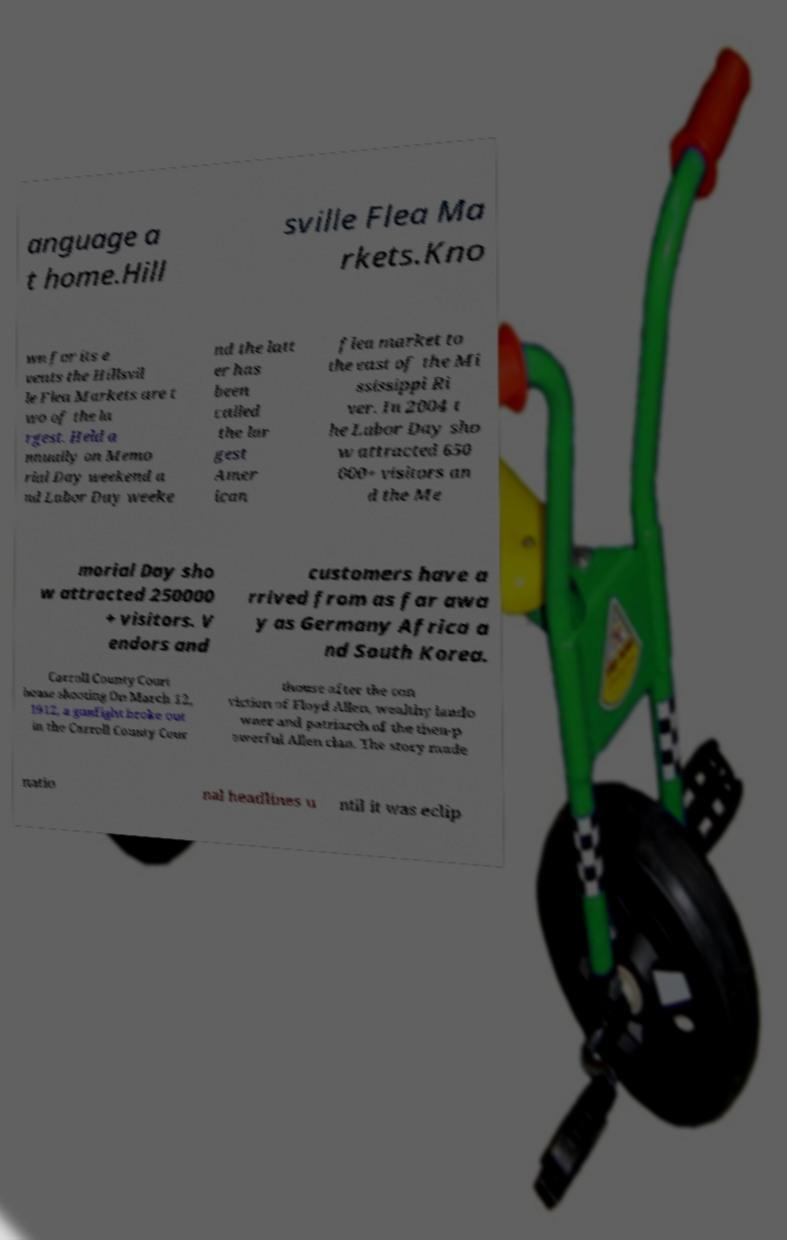Can you accurately transcribe the text from the provided image for me? anguage a t home.Hill sville Flea Ma rkets.Kno wn for its e vents the Hillsvil le Flea Markets are t wo of the la rgest. Held a nnually on Memo rial Day weekend a nd Labor Day weeke nd the latt er has been called the lar gest Amer ican flea market to the east of the Mi ssissippi Ri ver. In 2004 t he Labor Day sho w attracted 650 000+ visitors an d the Me morial Day sho w attracted 250000 + visitors. V endors and customers have a rrived from as far awa y as Germany Africa a nd South Korea. Carroll County Court house shooting.On March 12, 1912, a gunfight broke out in the Carroll County Cour thouse after the con viction of Floyd Allen, wealthy lando wner and patriarch of the then-p owerful Allen clan. The story made natio nal headlines u ntil it was eclip 